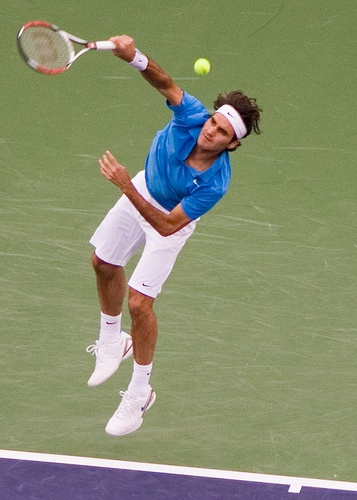Describe the objects in this image and their specific colors. I can see people in olive, lavender, blue, and maroon tones, tennis racket in olive, gray, darkgray, and lightgray tones, and sports ball in olive and khaki tones in this image. 